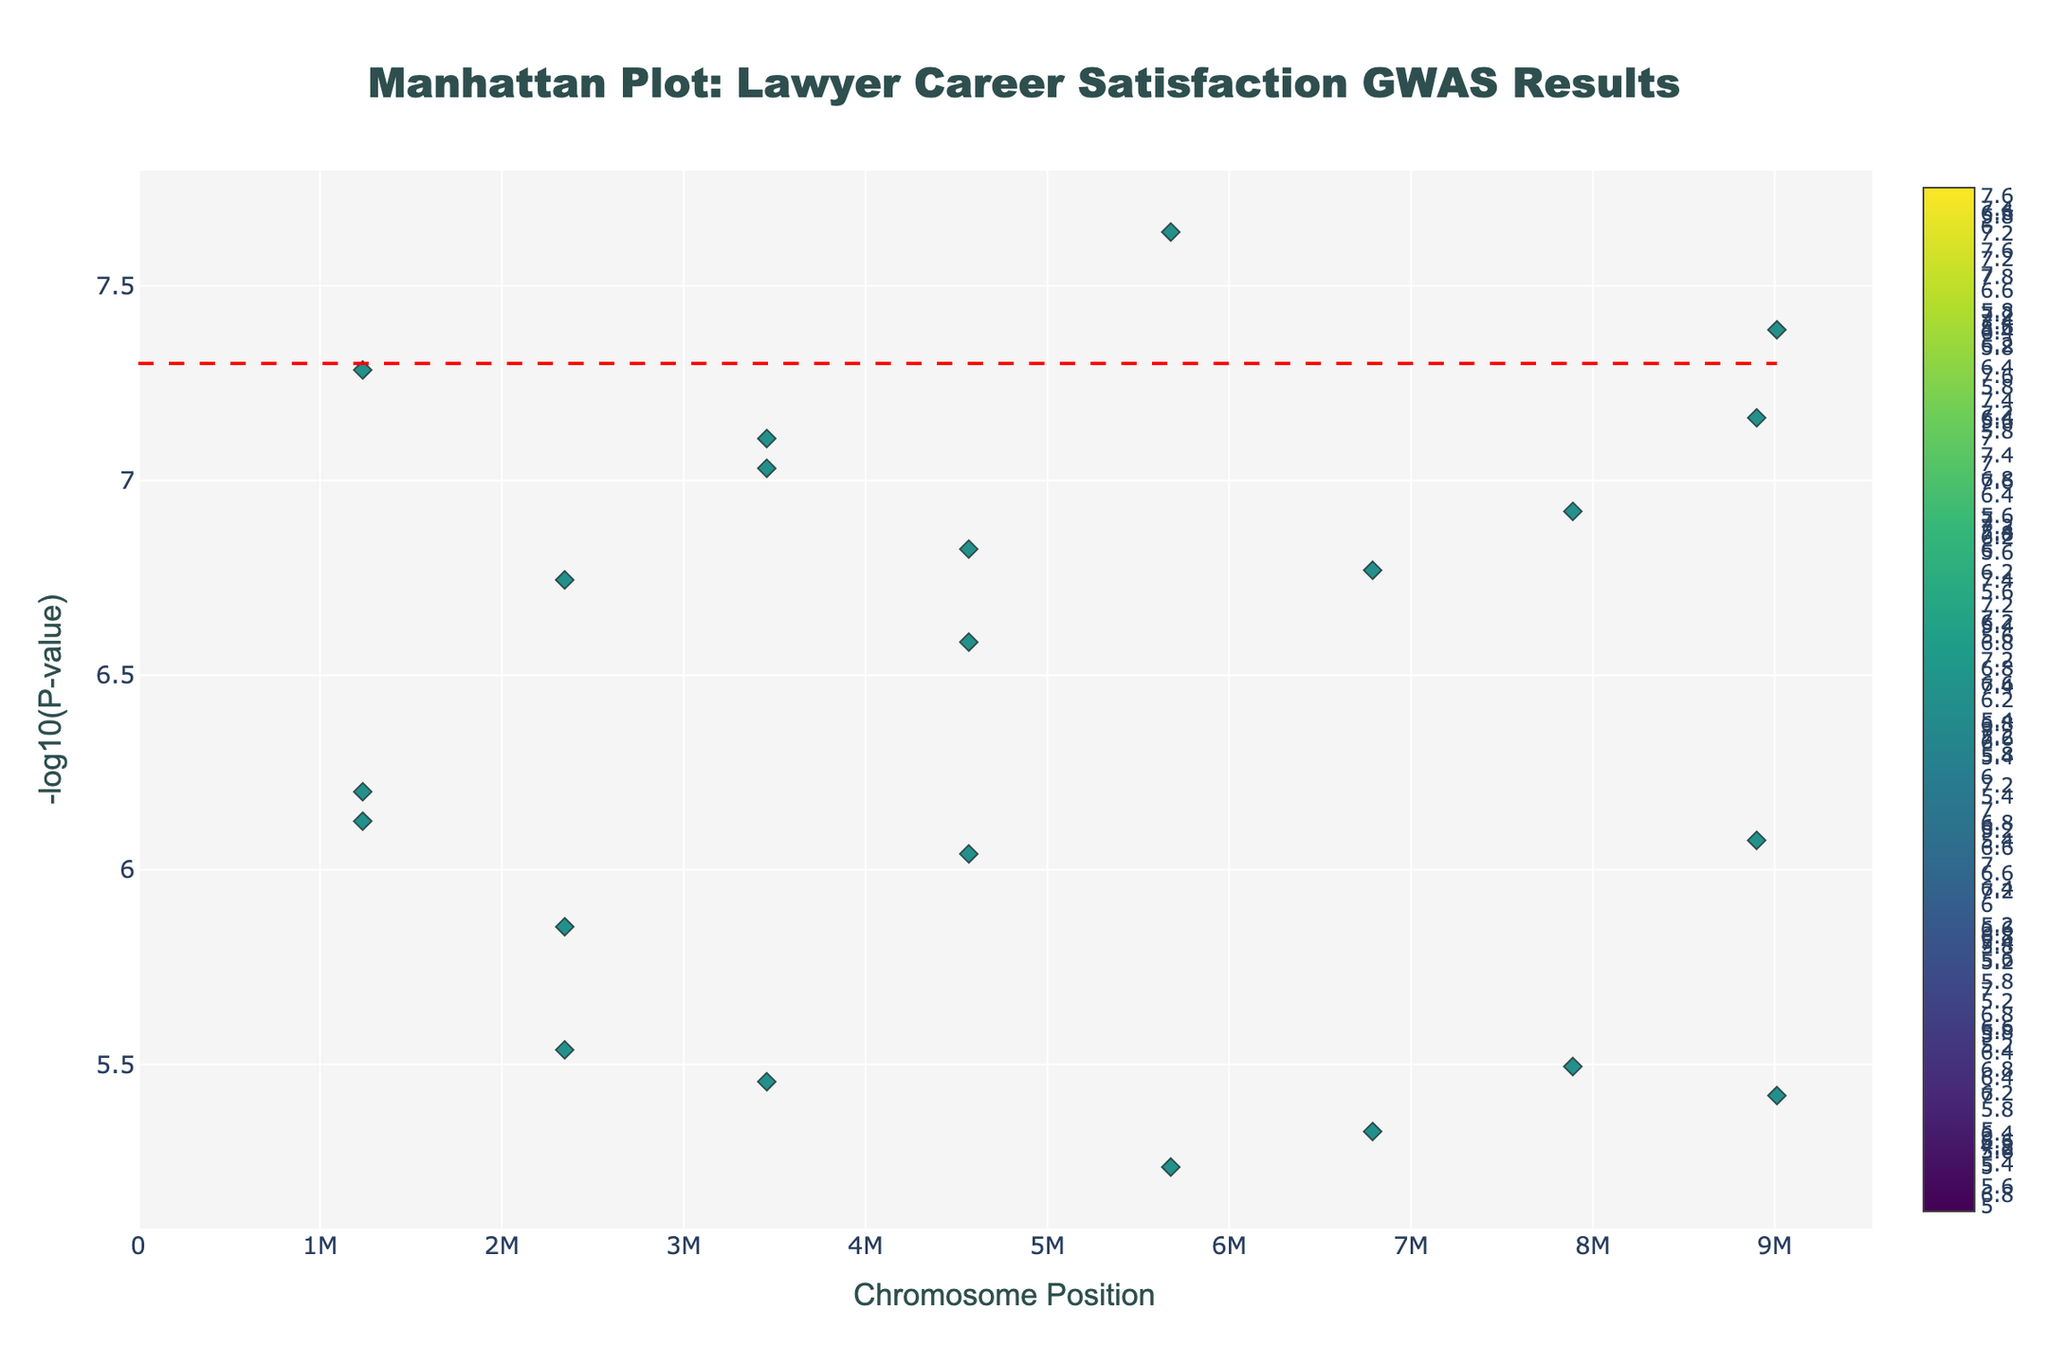What is the title of the plot? The title is displayed prominently at the top of the plot. It reads "Manhattan Plot: Lawyer Career Satisfaction GWAS Results".
Answer: Manhattan Plot: Lawyer Career Satisfaction GWAS Results What do the x-axis and y-axis represent? The x-axis represents the chromosome position, and the y-axis represents the negative logarithm of the P-values (-log10(P-value)). These are labeled clearly on the plot.
Answer: Chromosome position and -log10(P-value) Which practice area has the most significant P-value? The most significant P-value is the lowest value on the y-axis, which corresponds to the highest point on the plot. The highest point is for the gene COMT in Corporate Law.
Answer: Corporate Law How many genes have a P-value less than 1e-7? To find this, look for the y-axis values greater than 7 (since -log10(1e-7) = 7). There are several points above this threshold. Counting these points gives us the number of such genes: COMT in Corporate Law, MAOA in Environmental Law, BDNF in Real Estate Law, NPY in Civil Litigation, CACNA1C in Personal Injury, HTR1A in Public Interest Law, and GABRA6 in Insurance Law.
Answer: 7 Which chromosome has the gene with the second lowest P-value? To find this, first identify the gene with the second highest point on the plot after COMT in Corporate Law; it is MAOA in Environmental Law. The associated chromosome for this gene is chromosome 5.
Answer: Chromosome 5 What is the highest -log10(P-value) shown in the plot? The highest -log10(P-value) corresponds to the most significant P-value. This is observed at the highest point on the y-axis. From the plot, it is COMT in Corporate Law with a -log10(P-value) of slightly above 7.6.
Answer: Slightly above 7.6 Which practice areas are associated with genes located on chromosome 10? To determine this, find the points associated with chromosome 10 by looking at the x-axis labels beside them. Genes on chromosome 10 in the plot are FKBP5, and they are associated with Immigration Law.
Answer: Immigration Law Are there any chromosomes without significant points above the red line? The red line represents the significance threshold. Any chromosome without any points above this line does not have significant points. By visually inspecting, all chromosomes have at least one point above this line.
Answer: No How many genes lie above the significance threshold line? Count the number of points above the red dashed line, which represents the genome-wide significance threshold of -log10(5e-8). On careful counting, there are 9 such genes.
Answer: 9 Which practice area corresponds to the gene BDNF, and on which chromosome is it located? Locate the point labeled BDNF on the plot and check its hover information. BDNF is associated with Real Estate Law and is located on chromosome 7.
Answer: Real Estate Law, Chromosome 7 